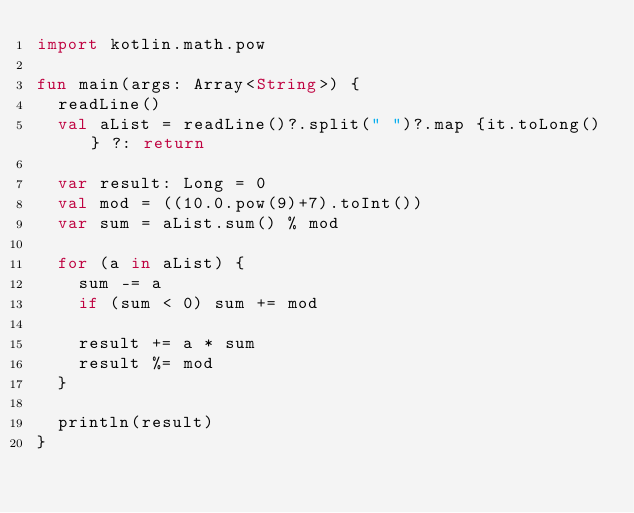Convert code to text. <code><loc_0><loc_0><loc_500><loc_500><_Kotlin_>import kotlin.math.pow

fun main(args: Array<String>) {
	readLine()
	val aList = readLine()?.split(" ")?.map {it.toLong()} ?: return
	
	var result: Long = 0
	val mod = ((10.0.pow(9)+7).toInt())
	var sum = aList.sum() % mod

	for (a in aList) {
		sum -= a
		if (sum < 0) sum += mod
		
		result += a * sum
		result %= mod
	}
	
	println(result)
}</code> 